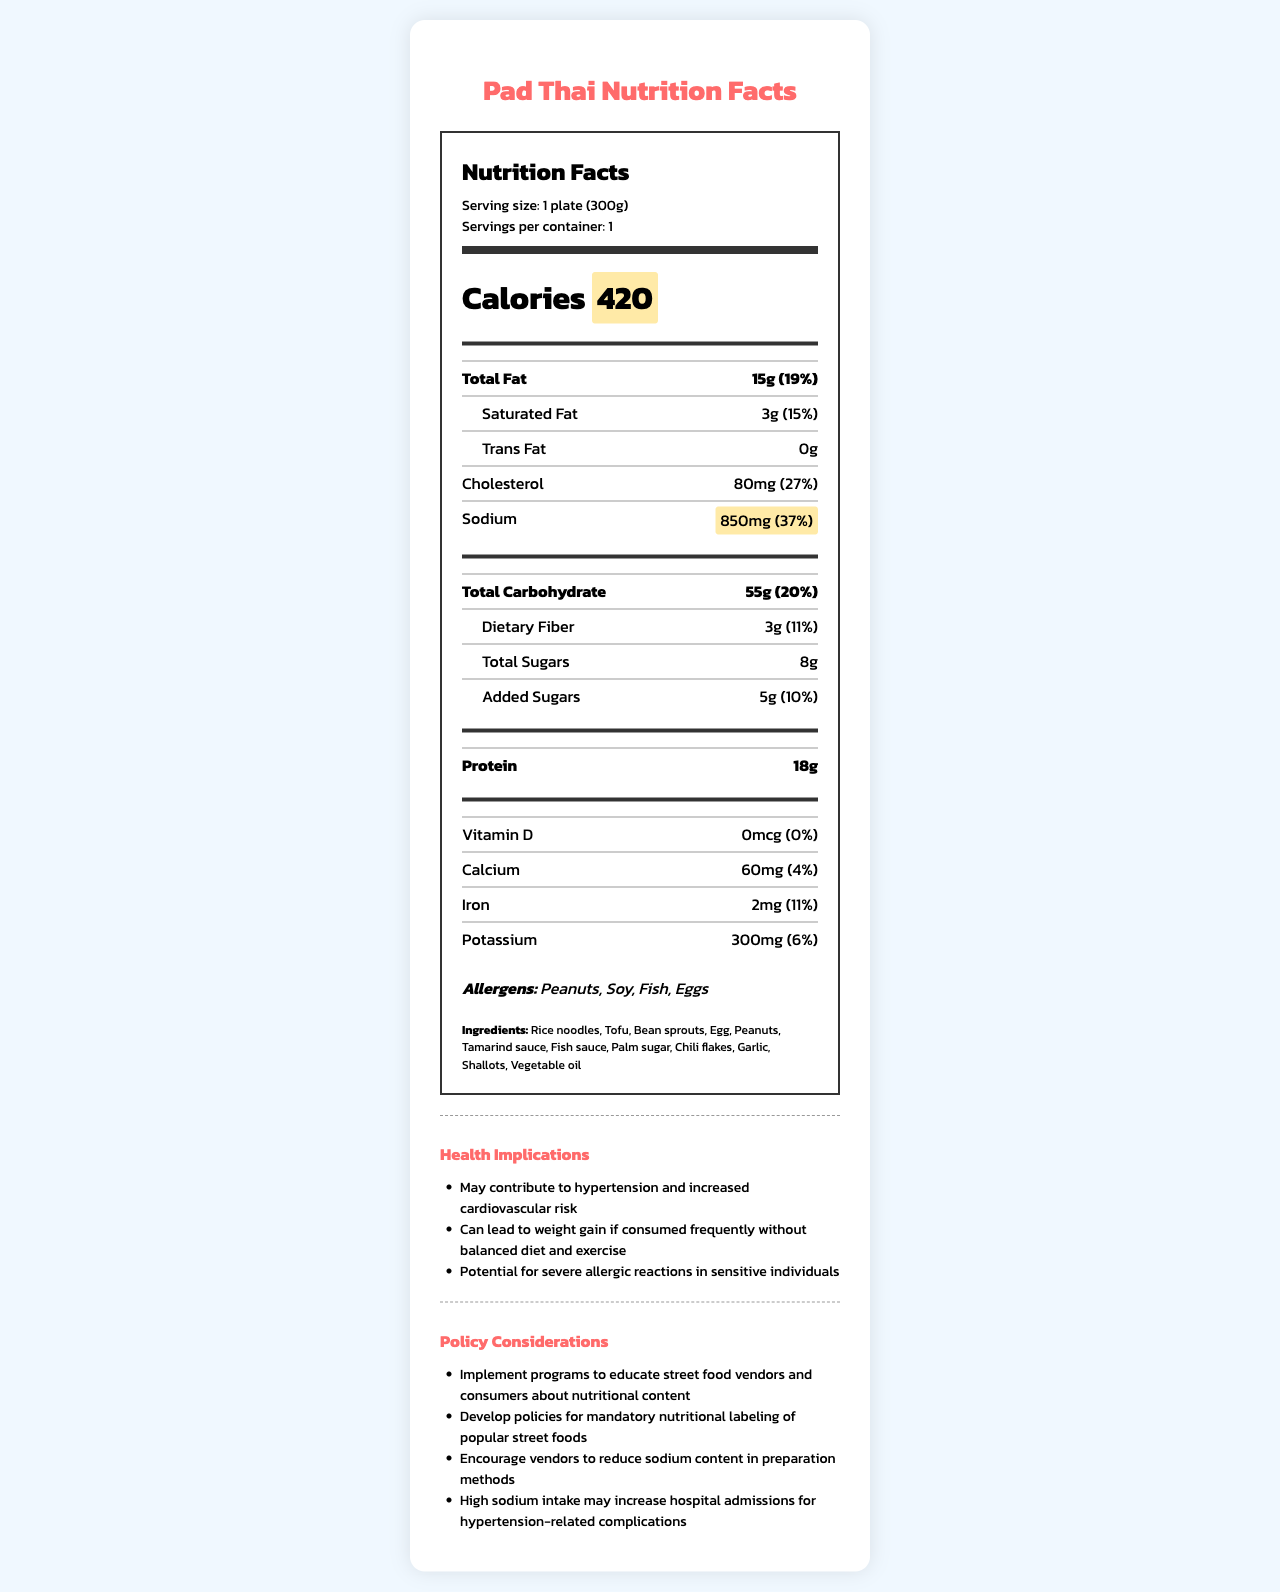what is the serving size of Pad Thai? The serving size is clearly stated in the document under "Serving size".
Answer: 1 plate (300g) how many calories does one serving of Pad Thai contain? The calories content is highlighted in the document next to the word "Calories".
Answer: 420 what percentage of daily value is the sodium content in Pad Thai? The sodium content and its percentage daily value are highlighted in the document.
Answer: 37% what are the main ingredients in Pad Thai? The main ingredients are listed at the bottom of the document under "Ingredients".
Answer: Rice noodles, Tofu, Bean sprouts, Egg, Peanuts, Tamarind sauce, Fish sauce, Palm sugar, Chili flakes, Garlic, Shallots, Vegetable oil what are the potential allergens in Pad Thai? The potential allergens are listed in the document under "Allergens".
Answer: Peanuts, Soy, Fish, Eggs which nutrient has the highest daily value percentage? A. Total Fat B. Sodium C. Cholesterol D. Protein Sodium has a daily value percentage of 37%, which is higher than the other listed nutrients.
Answer: B. Sodium how much cholesterol is in one serving of Pad Thai? A. 50mg B. 60mg C. 80mg D. 100mg The cholesterol content is listed as 80mg in the document.
Answer: C. 80mg is Pad Thai a high-calorie food? The document states that it contains 420 calories and labels it as "calorie_dense" under health implications.
Answer: Yes how might high sodium content in Pad Thai impact health? This information is provided under the "health_implications" section of the document.
Answer: May contribute to hypertension and increased cardiovascular risk summarize the main nutritional information presented in the document. The document is a comprehensive Nutrition Facts label that includes calorie, fat, carbohydrate, and protein content, as well as allergens, ingredients, and potential health impacts related to high sodium and calorie content.
Answer: The document provides a detailed nutritional breakdown of Pad Thai, including calorie and sodium content, along with total fat, carbohydrate, protein, and various vitamins and minerals. It highlights high calorie and sodium levels and lists potential health implications and policy considerations. what is the total daily value percentage of dietary fiber? The daily value percentage for dietary fiber is listed as 11% in the document.
Answer: 11% what kind of educational programs does the document suggest implementing? There is no specific information about the type of educational programs in the document.
Answer: Cannot be determined 